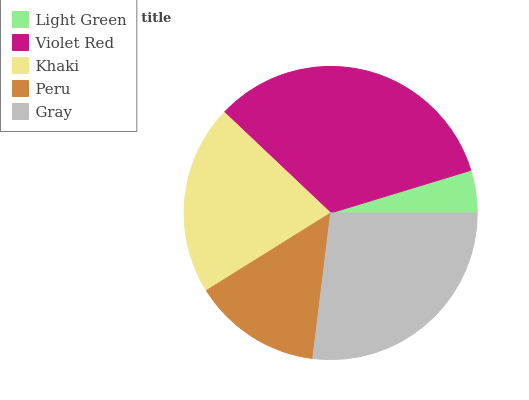Is Light Green the minimum?
Answer yes or no. Yes. Is Violet Red the maximum?
Answer yes or no. Yes. Is Khaki the minimum?
Answer yes or no. No. Is Khaki the maximum?
Answer yes or no. No. Is Violet Red greater than Khaki?
Answer yes or no. Yes. Is Khaki less than Violet Red?
Answer yes or no. Yes. Is Khaki greater than Violet Red?
Answer yes or no. No. Is Violet Red less than Khaki?
Answer yes or no. No. Is Khaki the high median?
Answer yes or no. Yes. Is Khaki the low median?
Answer yes or no. Yes. Is Violet Red the high median?
Answer yes or no. No. Is Peru the low median?
Answer yes or no. No. 